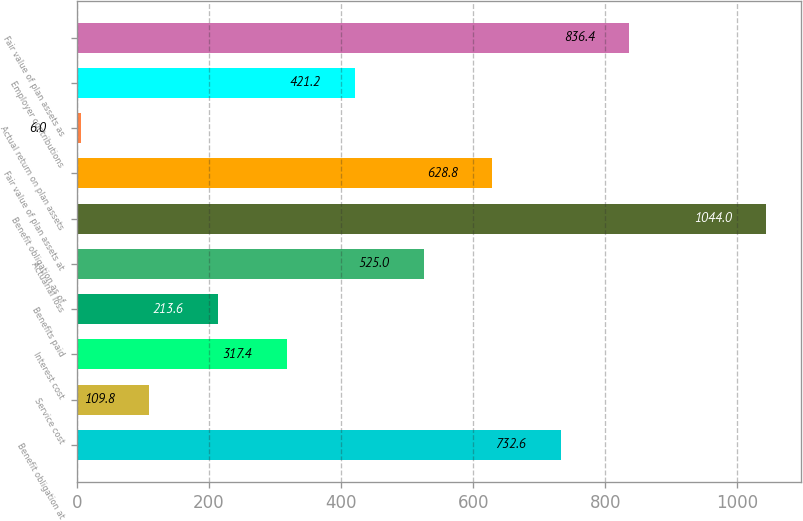Convert chart. <chart><loc_0><loc_0><loc_500><loc_500><bar_chart><fcel>Benefit obligation at<fcel>Service cost<fcel>Interest cost<fcel>Benefits paid<fcel>Actuarial loss<fcel>Benefit obligation as of<fcel>Fair value of plan assets at<fcel>Actual return on plan assets<fcel>Employer contributions<fcel>Fair value of plan assets as<nl><fcel>732.6<fcel>109.8<fcel>317.4<fcel>213.6<fcel>525<fcel>1044<fcel>628.8<fcel>6<fcel>421.2<fcel>836.4<nl></chart> 